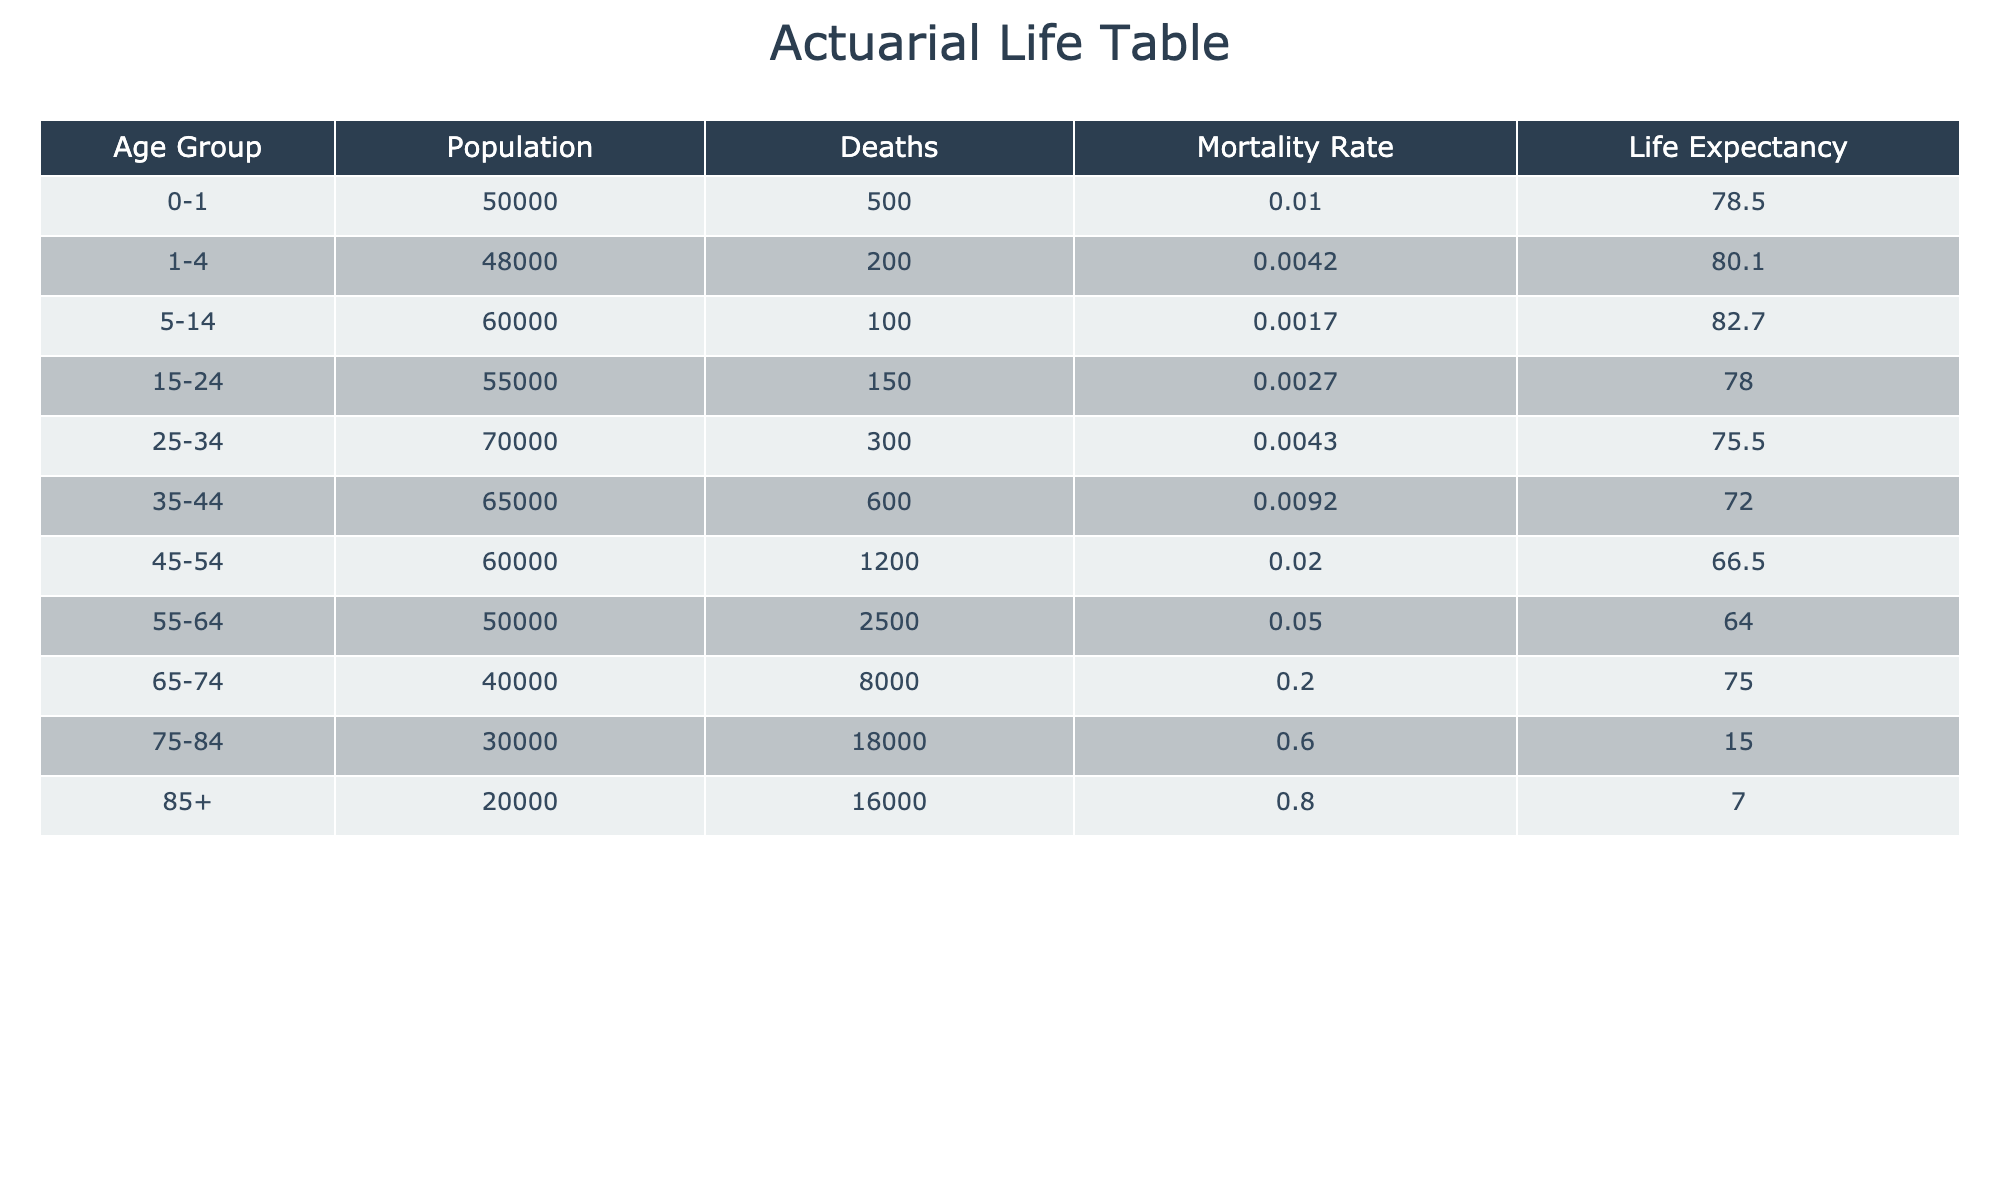What is the mortality rate for the age group 75-84? The table shows that the mortality rate for the age group 75-84 is 0.6000.
Answer: 0.6000 Which age group has the highest life expectancy? The age group 5-14 has the highest life expectancy at 82.7.
Answer: 82.7 How many deaths occurred in the age group 45-54? The table indicates that there were 1200 deaths in the age group 45-54.
Answer: 1200 What is the average mortality rate for all age groups? To find the average mortality rate, sum the mortality rates (0.0100 + 0.0042 + 0.0017 + 0.0027 + 0.0043 + 0.0092 + 0.0200 + 0.0500 + 0.2000 + 0.6000 + 0.8000) = 1.9001. There are 11 groups, so the average is 1.9001 / 11 = 0.1727.
Answer: 0.1727 Is the life expectancy for the age group 85+ lower than that for the age group 75-84? The life expectancy for the age group 85+ is 7.0 years, while for the age group 75-84 it’s 15.0 years. 7.0 is lower than 15.0, so the statement is true.
Answer: Yes Which age group has the second lowest mortality rate? The second lowest mortality rate is found in the age group 1-4, which is 0.0042.
Answer: 0.0042 What is the total population of all age groups combined? The total population is obtained by adding the populations of all age groups: (50000 + 48000 + 60000 + 55000 + 70000 + 65000 + 60000 + 50000 + 40000 + 30000 + 20000) = 50,000 + 48,000 + 60,000 + 55,000 + 70,000 + 65,000 + 60,000 + 50,000 + 40,000 + 30,000 + 20,000 = 500,000.
Answer: 500000 What percentage of the population aged 65-74 has died? To find the percentage, use the formula (deaths/population) * 100 = (8000/40000) * 100 = 20%.
Answer: 20% Is there an age group with a mortality rate over 0.5? Yes, the age groups 75-84 (0.6000) and 85+ (0.8000) both have mortality rates over 0.5.
Answer: Yes 